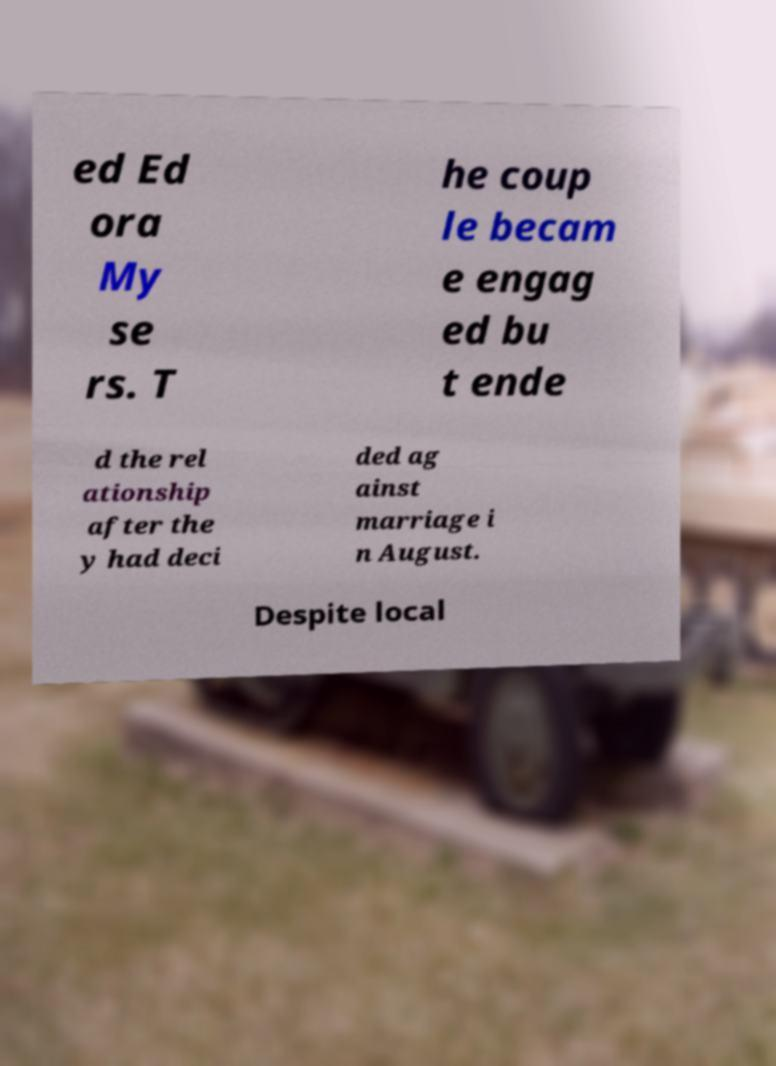Could you extract and type out the text from this image? ed Ed ora My se rs. T he coup le becam e engag ed bu t ende d the rel ationship after the y had deci ded ag ainst marriage i n August. Despite local 